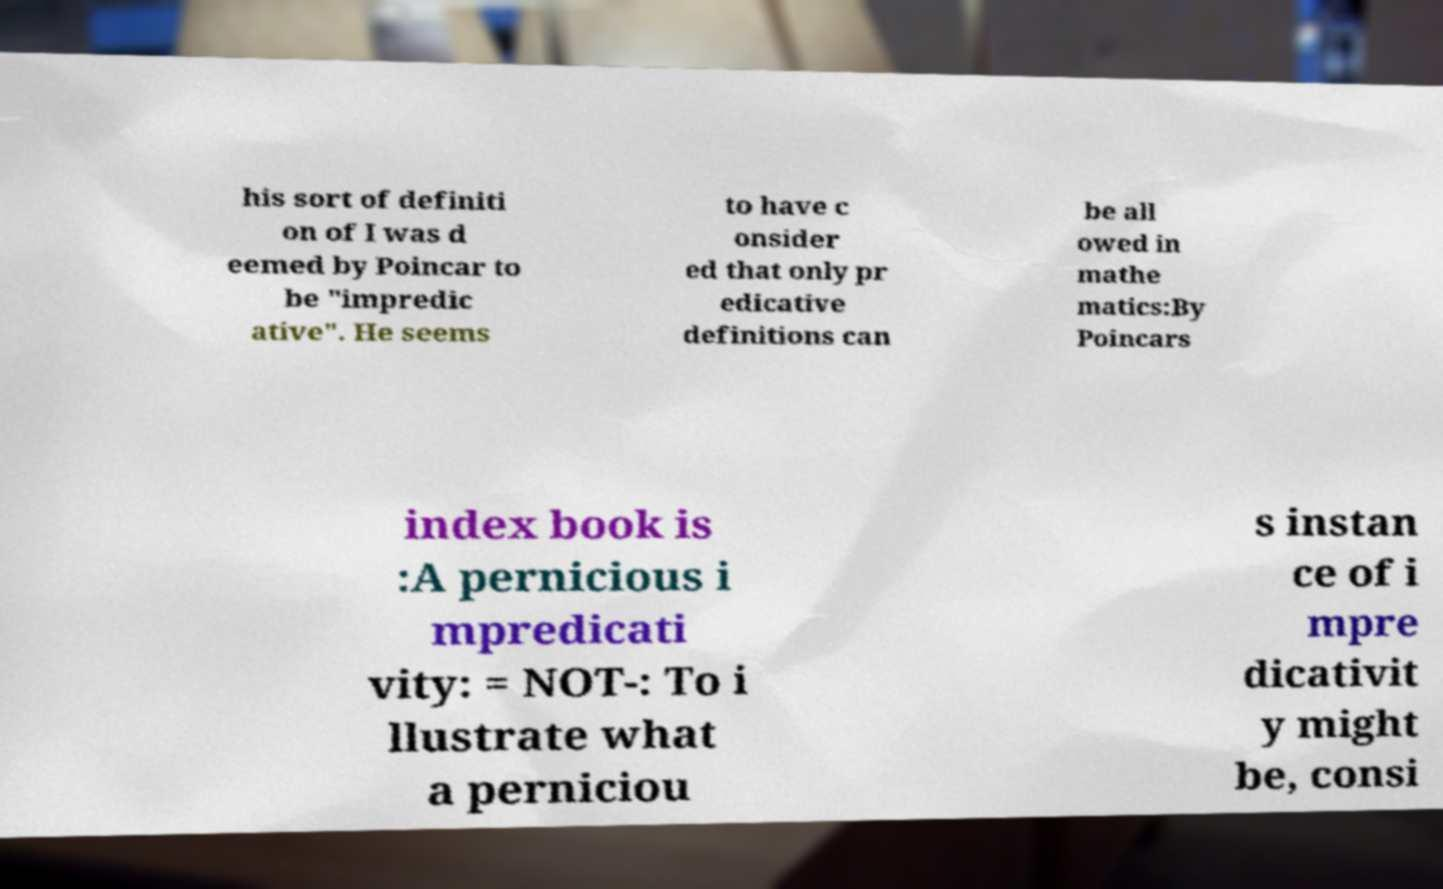Could you extract and type out the text from this image? his sort of definiti on of I was d eemed by Poincar to be "impredic ative". He seems to have c onsider ed that only pr edicative definitions can be all owed in mathe matics:By Poincars index book is :A pernicious i mpredicati vity: = NOT-: To i llustrate what a perniciou s instan ce of i mpre dicativit y might be, consi 